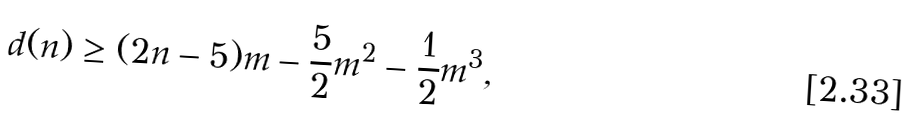<formula> <loc_0><loc_0><loc_500><loc_500>d ( n ) \geq ( 2 n - 5 ) m - \frac { 5 } { 2 } m ^ { 2 } - \frac { 1 } { 2 } m ^ { 3 } ,</formula> 